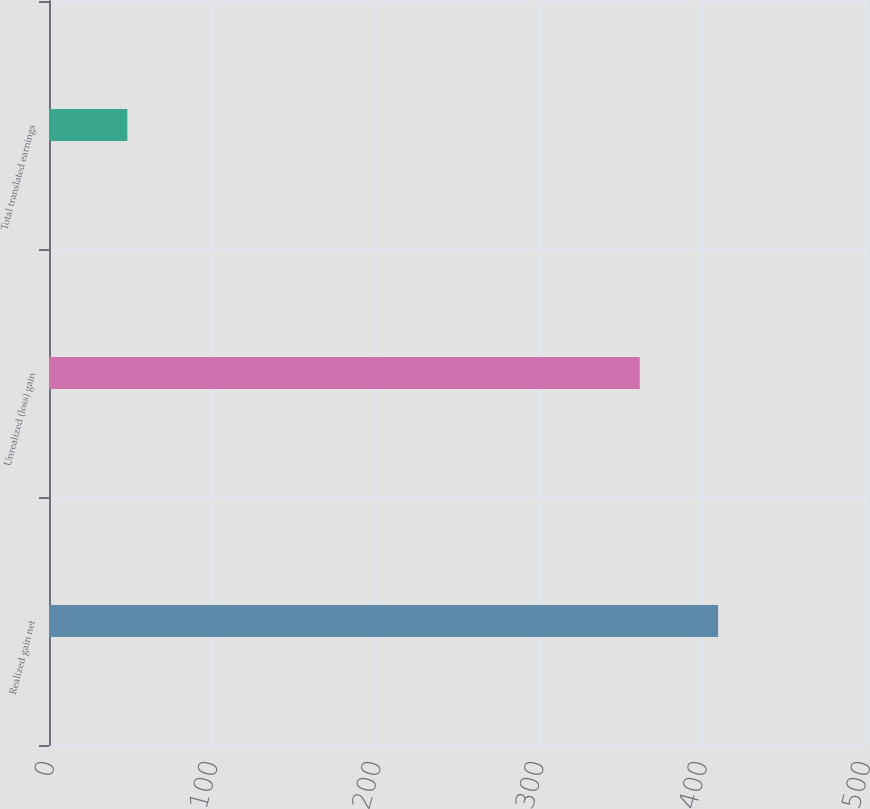Convert chart. <chart><loc_0><loc_0><loc_500><loc_500><bar_chart><fcel>Realized gain net<fcel>Unrealized (loss) gain<fcel>Total translated earnings<nl><fcel>410<fcel>362<fcel>48<nl></chart> 